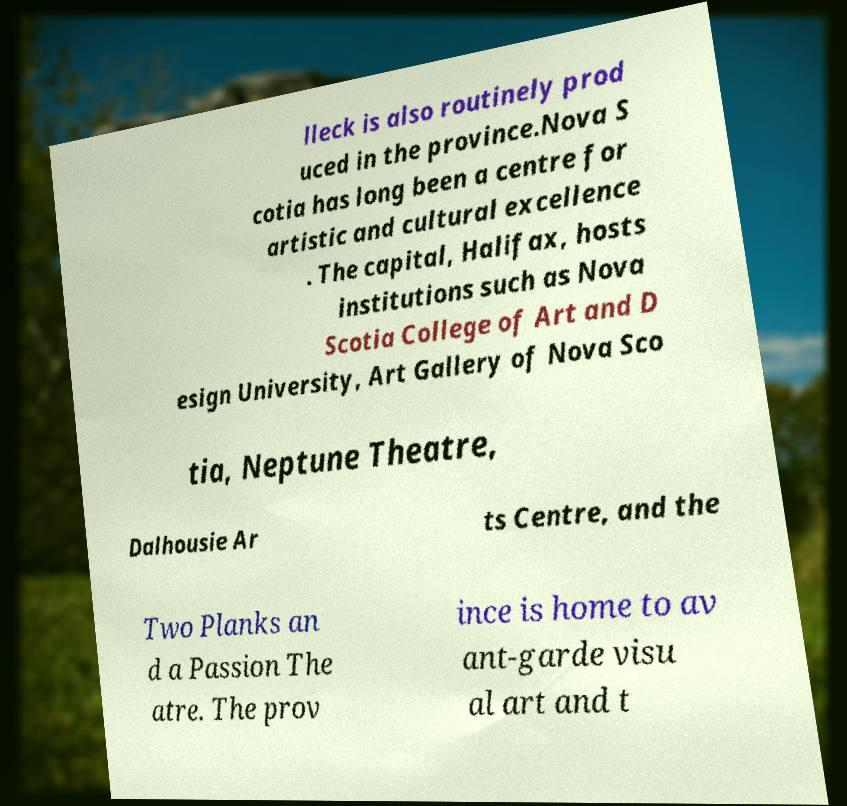I need the written content from this picture converted into text. Can you do that? lleck is also routinely prod uced in the province.Nova S cotia has long been a centre for artistic and cultural excellence . The capital, Halifax, hosts institutions such as Nova Scotia College of Art and D esign University, Art Gallery of Nova Sco tia, Neptune Theatre, Dalhousie Ar ts Centre, and the Two Planks an d a Passion The atre. The prov ince is home to av ant-garde visu al art and t 